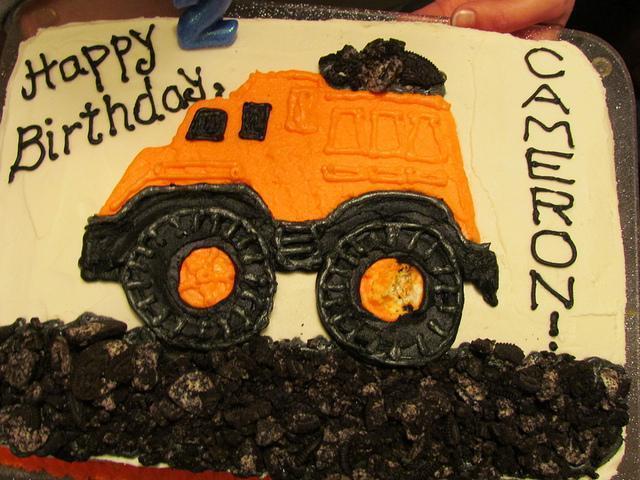Is the given caption "The cake is in front of the truck." fitting for the image?
Answer yes or no. No. Is the caption "The truck is on the cake." a true representation of the image?
Answer yes or no. Yes. 